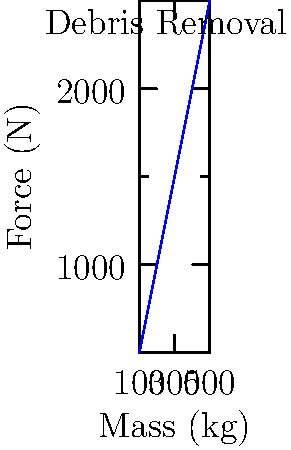As the head of the local disaster response committee, you're overseeing debris removal after a severe storm. The graph shows the relationship between the mass of debris and the force required to move it. If a piece of debris weighs 350 kg, what force would be needed to move it, assuming the relationship is linear? To solve this problem, we need to follow these steps:

1. Recognize that the graph shows a linear relationship between mass and force.

2. Find the slope of the line, which represents the change in force per unit change in mass:
   Slope = $\frac{\text{Change in Force}}{\text{Change in Mass}} = \frac{2500 \text{ N} - 500 \text{ N}}{500 \text{ kg} - 100 \text{ kg}} = \frac{2000 \text{ N}}{400 \text{ kg}} = 5 \text{ N/kg}$

3. Use the point-slope form of a linear equation: $y - y_1 = m(x - x_1)$
   Where $m$ is the slope, $(x_1, y_1)$ is a known point on the line, $x$ is our input (mass), and $y$ is our output (force).

4. Choose a known point, e.g., (100 kg, 500 N), and plug in our values:
   $F - 500 = 5(M - 100)$, where $F$ is force and $M$ is mass.

5. Substitute our given mass of 350 kg:
   $F - 500 = 5(350 - 100)$
   $F - 500 = 5(250) = 1250$

6. Solve for $F$:
   $F = 1250 + 500 = 1750$

Therefore, a force of 1750 N would be needed to move a piece of debris weighing 350 kg.
Answer: 1750 N 